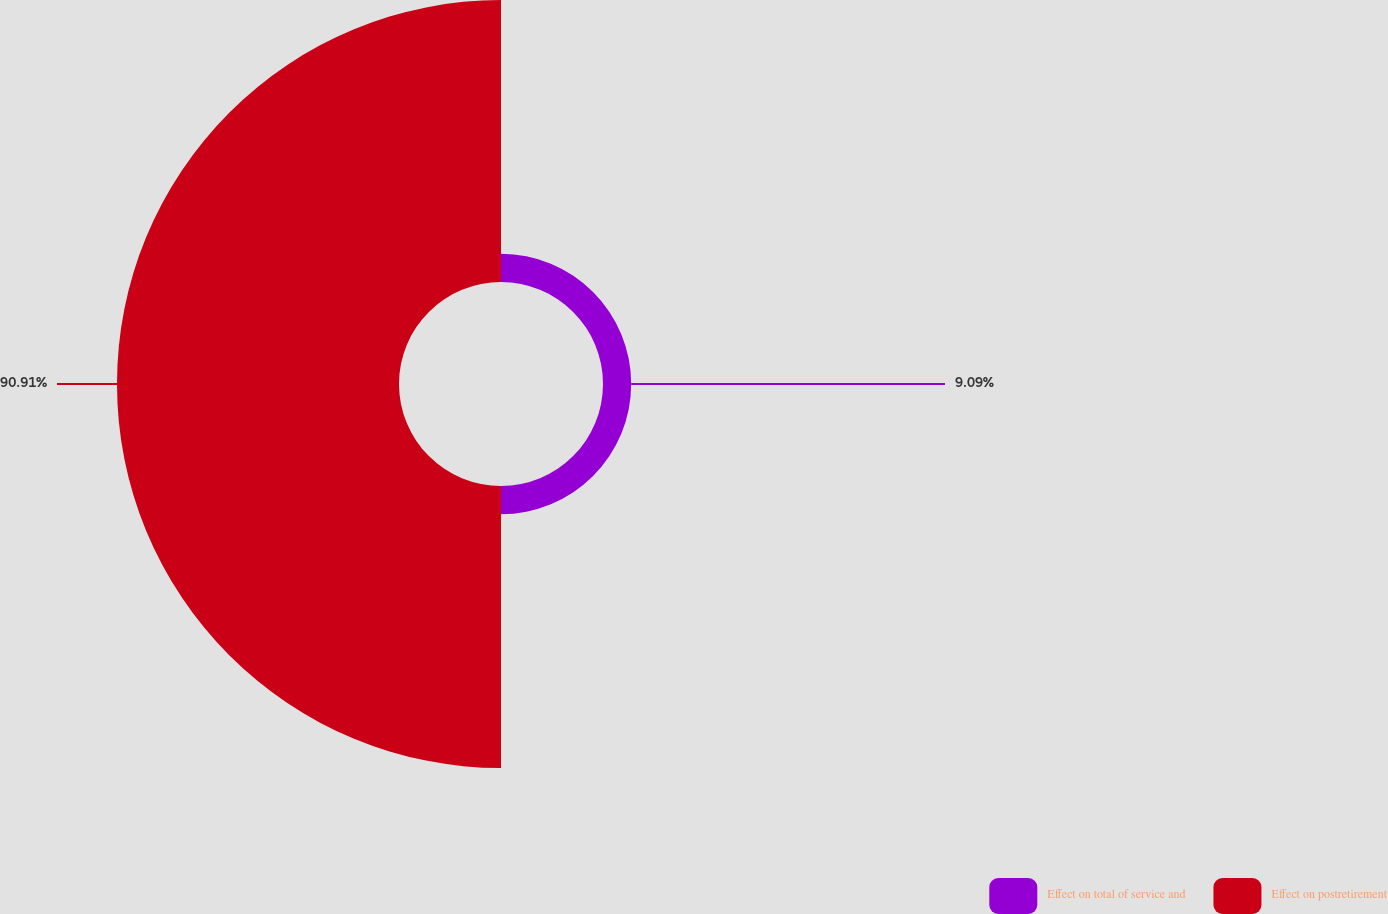Convert chart. <chart><loc_0><loc_0><loc_500><loc_500><pie_chart><fcel>Effect on total of service and<fcel>Effect on postretirement<nl><fcel>9.09%<fcel>90.91%<nl></chart> 